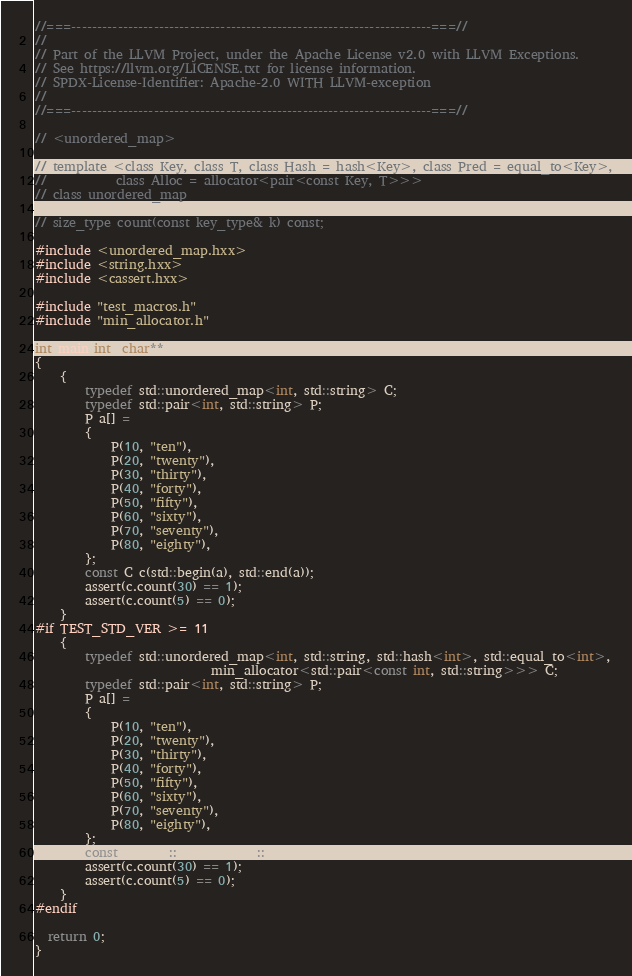Convert code to text. <code><loc_0><loc_0><loc_500><loc_500><_C++_>//===----------------------------------------------------------------------===//
//
// Part of the LLVM Project, under the Apache License v2.0 with LLVM Exceptions.
// See https://llvm.org/LICENSE.txt for license information.
// SPDX-License-Identifier: Apache-2.0 WITH LLVM-exception
//
//===----------------------------------------------------------------------===//

// <unordered_map>

// template <class Key, class T, class Hash = hash<Key>, class Pred = equal_to<Key>,
//           class Alloc = allocator<pair<const Key, T>>>
// class unordered_map

// size_type count(const key_type& k) const;

#include <unordered_map.hxx>
#include <string.hxx>
#include <cassert.hxx>

#include "test_macros.h"
#include "min_allocator.h"

int main(int, char**)
{
    {
        typedef std::unordered_map<int, std::string> C;
        typedef std::pair<int, std::string> P;
        P a[] =
        {
            P(10, "ten"),
            P(20, "twenty"),
            P(30, "thirty"),
            P(40, "forty"),
            P(50, "fifty"),
            P(60, "sixty"),
            P(70, "seventy"),
            P(80, "eighty"),
        };
        const C c(std::begin(a), std::end(a));
        assert(c.count(30) == 1);
        assert(c.count(5) == 0);
    }
#if TEST_STD_VER >= 11
    {
        typedef std::unordered_map<int, std::string, std::hash<int>, std::equal_to<int>,
                            min_allocator<std::pair<const int, std::string>>> C;
        typedef std::pair<int, std::string> P;
        P a[] =
        {
            P(10, "ten"),
            P(20, "twenty"),
            P(30, "thirty"),
            P(40, "forty"),
            P(50, "fifty"),
            P(60, "sixty"),
            P(70, "seventy"),
            P(80, "eighty"),
        };
        const C c(std::begin(a), std::end(a));
        assert(c.count(30) == 1);
        assert(c.count(5) == 0);
    }
#endif

  return 0;
}
</code> 